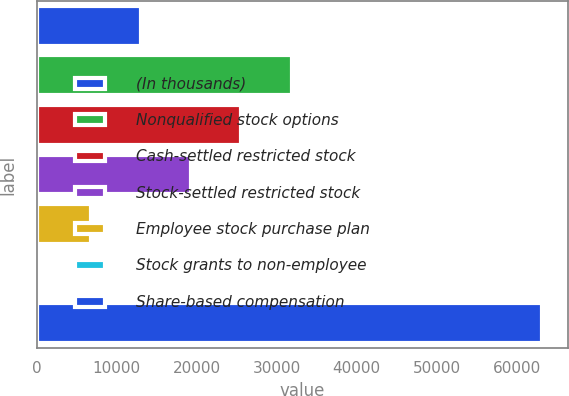Convert chart. <chart><loc_0><loc_0><loc_500><loc_500><bar_chart><fcel>(In thousands)<fcel>Nonqualified stock options<fcel>Cash-settled restricted stock<fcel>Stock-settled restricted stock<fcel>Employee stock purchase plan<fcel>Stock grants to non-employee<fcel>Share-based compensation<nl><fcel>13074.8<fcel>31862<fcel>25599.6<fcel>19337.2<fcel>6812.4<fcel>550<fcel>63174<nl></chart> 